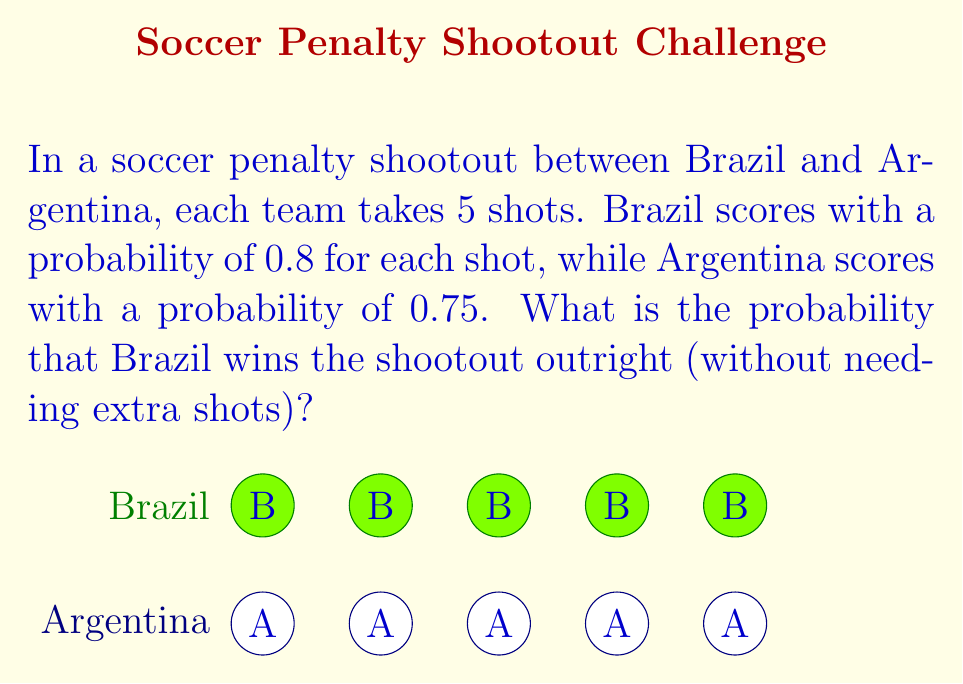Teach me how to tackle this problem. Let's approach this step-by-step:

1) For Brazil to win outright, they need to score more goals than Argentina after 5 shots each.

2) The probability of Brazil scoring exactly $k$ goals out of 5 shots follows a binomial distribution:

   $P(\text{Brazil} = k) = \binom{5}{k} (0.8)^k (0.2)^{5-k}$

3) Similarly, for Argentina:

   $P(\text{Argentina} = j) = \binom{5}{j} (0.75)^j (0.25)^{5-j}$

4) Brazil wins if their score is higher than Argentina's. We need to sum the probabilities of all possible winning scenarios:

   $P(\text{Brazil wins}) = \sum_{k=1}^5 P(\text{Brazil} = k) \cdot \sum_{j=0}^{k-1} P(\text{Argentina} = j)$

5) Let's calculate this:

   $P(\text{Brazil wins}) = \\
   (0.8^5) \cdot (0.25^5) + \\
   \binom{5}{4}(0.8^4)(0.2) \cdot [(0.25^5) + \binom{5}{1}(0.75)(0.25^4)] + \\
   \binom{5}{3}(0.8^3)(0.2^2) \cdot [(0.25^5) + \binom{5}{1}(0.75)(0.25^4) + \binom{5}{2}(0.75^2)(0.25^3)] + \\
   \binom{5}{2}(0.8^2)(0.2^3) \cdot [(0.25^5) + \binom{5}{1}(0.75)(0.25^4)] + \\
   \binom{5}{1}(0.8)(0.2^4) \cdot (0.25^5)$

6) Calculating this gives us approximately 0.5998.
Answer: $\approx 0.5998$ 